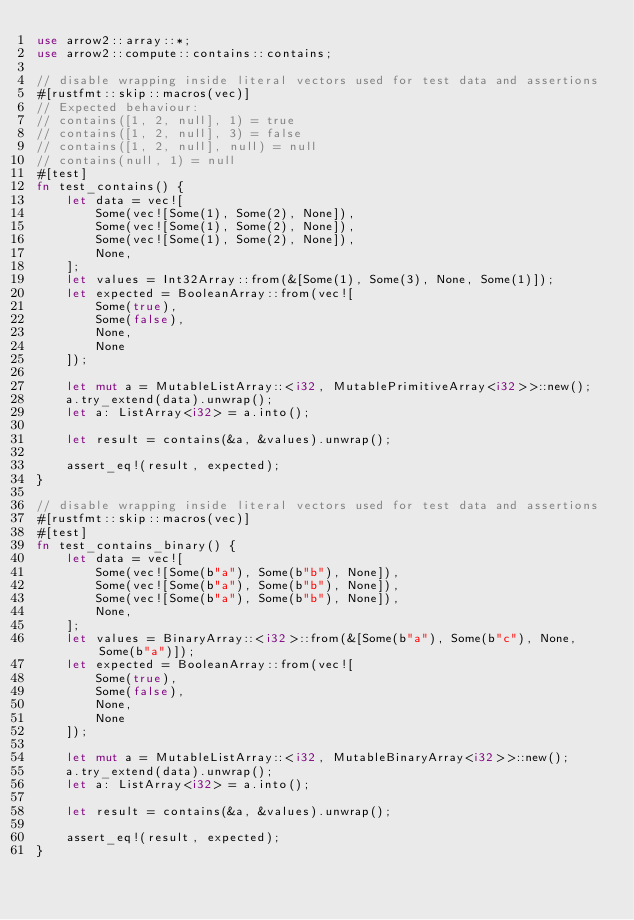Convert code to text. <code><loc_0><loc_0><loc_500><loc_500><_Rust_>use arrow2::array::*;
use arrow2::compute::contains::contains;

// disable wrapping inside literal vectors used for test data and assertions
#[rustfmt::skip::macros(vec)]
// Expected behaviour:
// contains([1, 2, null], 1) = true
// contains([1, 2, null], 3) = false
// contains([1, 2, null], null) = null
// contains(null, 1) = null
#[test]
fn test_contains() {
    let data = vec![
        Some(vec![Some(1), Some(2), None]),
        Some(vec![Some(1), Some(2), None]),
        Some(vec![Some(1), Some(2), None]),
        None,
    ];
    let values = Int32Array::from(&[Some(1), Some(3), None, Some(1)]);
    let expected = BooleanArray::from(vec![
        Some(true),
        Some(false),
        None,
        None
    ]);

    let mut a = MutableListArray::<i32, MutablePrimitiveArray<i32>>::new();
    a.try_extend(data).unwrap();
    let a: ListArray<i32> = a.into();

    let result = contains(&a, &values).unwrap();

    assert_eq!(result, expected);
}

// disable wrapping inside literal vectors used for test data and assertions
#[rustfmt::skip::macros(vec)]
#[test]
fn test_contains_binary() {
    let data = vec![
        Some(vec![Some(b"a"), Some(b"b"), None]),
        Some(vec![Some(b"a"), Some(b"b"), None]),
        Some(vec![Some(b"a"), Some(b"b"), None]),
        None,
    ];
    let values = BinaryArray::<i32>::from(&[Some(b"a"), Some(b"c"), None, Some(b"a")]);
    let expected = BooleanArray::from(vec![
        Some(true),
        Some(false),
        None,
        None
    ]);

    let mut a = MutableListArray::<i32, MutableBinaryArray<i32>>::new();
    a.try_extend(data).unwrap();
    let a: ListArray<i32> = a.into();

    let result = contains(&a, &values).unwrap();

    assert_eq!(result, expected);
}
</code> 